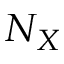<formula> <loc_0><loc_0><loc_500><loc_500>N _ { X }</formula> 